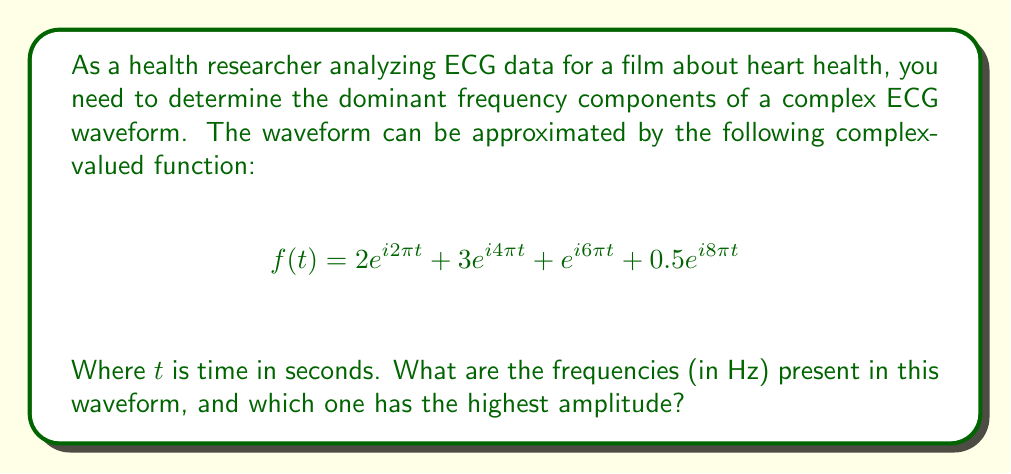What is the answer to this math problem? To analyze the frequency components of this complex waveform, we need to understand the structure of the given function:

$$f(t) = 2e^{i2\pi t} + 3e^{i4\pi t} + e^{i6\pi t} + 0.5e^{i8\pi t}$$

1. In the general form $Ae^{i\omega t}$, $\omega$ represents the angular frequency in radians per second, and $A$ represents the amplitude.

2. To convert angular frequency to Hz, we use the relation: $f = \frac{\omega}{2\pi}$

3. Let's analyze each term:

   a) $2e^{i2\pi t}$: 
      $\omega = 2\pi$, so $f = \frac{2\pi}{2\pi} = 1$ Hz
      Amplitude = 2

   b) $3e^{i4\pi t}$: 
      $\omega = 4\pi$, so $f = \frac{4\pi}{2\pi} = 2$ Hz
      Amplitude = 3

   c) $e^{i6\pi t}$: 
      $\omega = 6\pi$, so $f = \frac{6\pi}{2\pi} = 3$ Hz
      Amplitude = 1

   d) $0.5e^{i8\pi t}$: 
      $\omega = 8\pi$, so $f = \frac{8\pi}{2\pi} = 4$ Hz
      Amplitude = 0.5

4. The frequencies present are 1 Hz, 2 Hz, 3 Hz, and 4 Hz.

5. The highest amplitude is 3, corresponding to the 2 Hz component.
Answer: The frequencies present in the waveform are 1 Hz, 2 Hz, 3 Hz, and 4 Hz. The dominant frequency component with the highest amplitude is 2 Hz. 